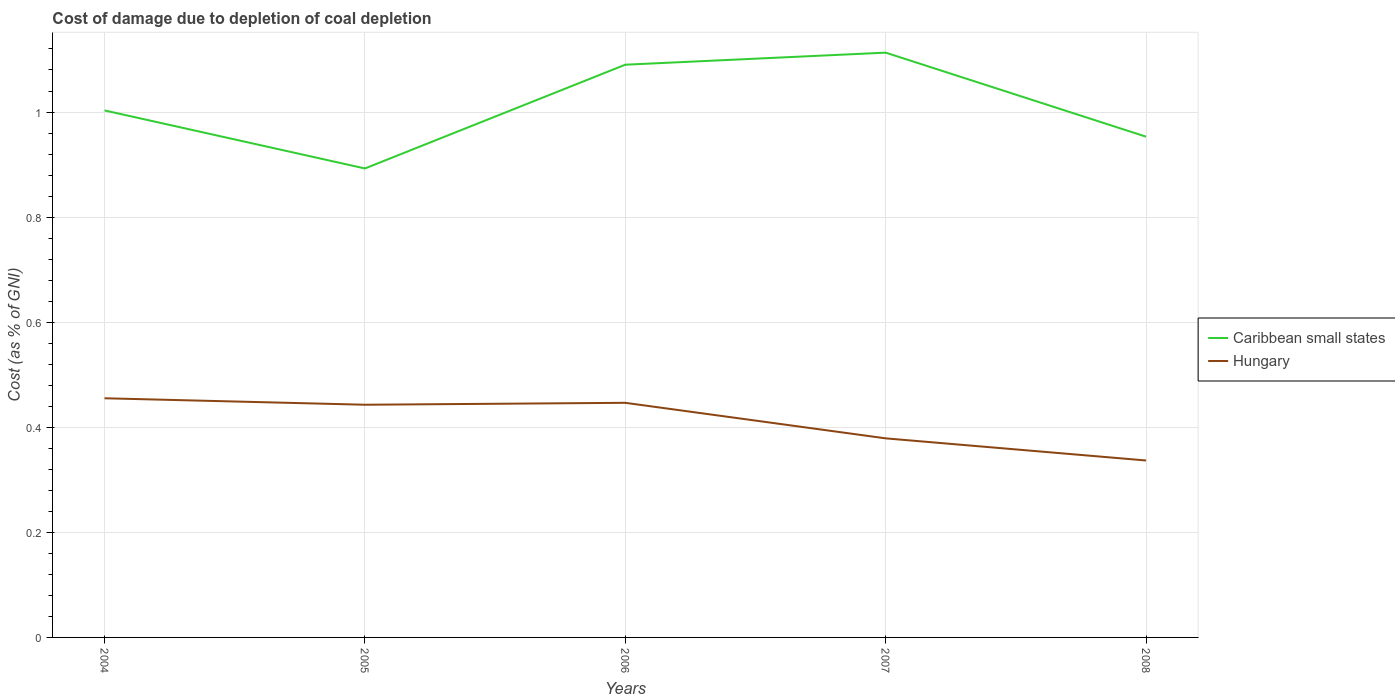Is the number of lines equal to the number of legend labels?
Your response must be concise. Yes. Across all years, what is the maximum cost of damage caused due to coal depletion in Hungary?
Your response must be concise. 0.34. In which year was the cost of damage caused due to coal depletion in Hungary maximum?
Offer a very short reply. 2008. What is the total cost of damage caused due to coal depletion in Hungary in the graph?
Your response must be concise. 0.12. What is the difference between the highest and the second highest cost of damage caused due to coal depletion in Caribbean small states?
Offer a very short reply. 0.22. What is the difference between the highest and the lowest cost of damage caused due to coal depletion in Hungary?
Provide a short and direct response. 3. Is the cost of damage caused due to coal depletion in Hungary strictly greater than the cost of damage caused due to coal depletion in Caribbean small states over the years?
Provide a short and direct response. Yes. Does the graph contain any zero values?
Your answer should be very brief. No. Where does the legend appear in the graph?
Your answer should be compact. Center right. How many legend labels are there?
Make the answer very short. 2. How are the legend labels stacked?
Make the answer very short. Vertical. What is the title of the graph?
Offer a terse response. Cost of damage due to depletion of coal depletion. What is the label or title of the X-axis?
Offer a very short reply. Years. What is the label or title of the Y-axis?
Ensure brevity in your answer.  Cost (as % of GNI). What is the Cost (as % of GNI) of Caribbean small states in 2004?
Offer a very short reply. 1. What is the Cost (as % of GNI) of Hungary in 2004?
Your answer should be very brief. 0.46. What is the Cost (as % of GNI) in Caribbean small states in 2005?
Keep it short and to the point. 0.89. What is the Cost (as % of GNI) of Hungary in 2005?
Offer a terse response. 0.44. What is the Cost (as % of GNI) in Caribbean small states in 2006?
Make the answer very short. 1.09. What is the Cost (as % of GNI) in Hungary in 2006?
Your answer should be very brief. 0.45. What is the Cost (as % of GNI) in Caribbean small states in 2007?
Ensure brevity in your answer.  1.11. What is the Cost (as % of GNI) in Hungary in 2007?
Provide a succinct answer. 0.38. What is the Cost (as % of GNI) in Caribbean small states in 2008?
Your answer should be compact. 0.95. What is the Cost (as % of GNI) of Hungary in 2008?
Offer a very short reply. 0.34. Across all years, what is the maximum Cost (as % of GNI) in Caribbean small states?
Make the answer very short. 1.11. Across all years, what is the maximum Cost (as % of GNI) in Hungary?
Make the answer very short. 0.46. Across all years, what is the minimum Cost (as % of GNI) in Caribbean small states?
Ensure brevity in your answer.  0.89. Across all years, what is the minimum Cost (as % of GNI) in Hungary?
Make the answer very short. 0.34. What is the total Cost (as % of GNI) of Caribbean small states in the graph?
Your answer should be very brief. 5.05. What is the total Cost (as % of GNI) of Hungary in the graph?
Your answer should be very brief. 2.06. What is the difference between the Cost (as % of GNI) in Caribbean small states in 2004 and that in 2005?
Offer a terse response. 0.11. What is the difference between the Cost (as % of GNI) of Hungary in 2004 and that in 2005?
Make the answer very short. 0.01. What is the difference between the Cost (as % of GNI) in Caribbean small states in 2004 and that in 2006?
Give a very brief answer. -0.09. What is the difference between the Cost (as % of GNI) of Hungary in 2004 and that in 2006?
Make the answer very short. 0.01. What is the difference between the Cost (as % of GNI) in Caribbean small states in 2004 and that in 2007?
Ensure brevity in your answer.  -0.11. What is the difference between the Cost (as % of GNI) of Hungary in 2004 and that in 2007?
Keep it short and to the point. 0.08. What is the difference between the Cost (as % of GNI) in Caribbean small states in 2004 and that in 2008?
Your response must be concise. 0.05. What is the difference between the Cost (as % of GNI) of Hungary in 2004 and that in 2008?
Give a very brief answer. 0.12. What is the difference between the Cost (as % of GNI) of Caribbean small states in 2005 and that in 2006?
Provide a succinct answer. -0.2. What is the difference between the Cost (as % of GNI) in Hungary in 2005 and that in 2006?
Make the answer very short. -0. What is the difference between the Cost (as % of GNI) in Caribbean small states in 2005 and that in 2007?
Offer a terse response. -0.22. What is the difference between the Cost (as % of GNI) in Hungary in 2005 and that in 2007?
Offer a very short reply. 0.06. What is the difference between the Cost (as % of GNI) in Caribbean small states in 2005 and that in 2008?
Your response must be concise. -0.06. What is the difference between the Cost (as % of GNI) in Hungary in 2005 and that in 2008?
Provide a short and direct response. 0.11. What is the difference between the Cost (as % of GNI) in Caribbean small states in 2006 and that in 2007?
Offer a very short reply. -0.02. What is the difference between the Cost (as % of GNI) of Hungary in 2006 and that in 2007?
Ensure brevity in your answer.  0.07. What is the difference between the Cost (as % of GNI) of Caribbean small states in 2006 and that in 2008?
Ensure brevity in your answer.  0.14. What is the difference between the Cost (as % of GNI) of Hungary in 2006 and that in 2008?
Make the answer very short. 0.11. What is the difference between the Cost (as % of GNI) of Caribbean small states in 2007 and that in 2008?
Your answer should be very brief. 0.16. What is the difference between the Cost (as % of GNI) of Hungary in 2007 and that in 2008?
Your answer should be compact. 0.04. What is the difference between the Cost (as % of GNI) in Caribbean small states in 2004 and the Cost (as % of GNI) in Hungary in 2005?
Offer a terse response. 0.56. What is the difference between the Cost (as % of GNI) of Caribbean small states in 2004 and the Cost (as % of GNI) of Hungary in 2006?
Make the answer very short. 0.56. What is the difference between the Cost (as % of GNI) of Caribbean small states in 2004 and the Cost (as % of GNI) of Hungary in 2007?
Provide a short and direct response. 0.62. What is the difference between the Cost (as % of GNI) in Caribbean small states in 2004 and the Cost (as % of GNI) in Hungary in 2008?
Offer a very short reply. 0.67. What is the difference between the Cost (as % of GNI) of Caribbean small states in 2005 and the Cost (as % of GNI) of Hungary in 2006?
Provide a succinct answer. 0.45. What is the difference between the Cost (as % of GNI) in Caribbean small states in 2005 and the Cost (as % of GNI) in Hungary in 2007?
Your answer should be compact. 0.51. What is the difference between the Cost (as % of GNI) in Caribbean small states in 2005 and the Cost (as % of GNI) in Hungary in 2008?
Ensure brevity in your answer.  0.56. What is the difference between the Cost (as % of GNI) of Caribbean small states in 2006 and the Cost (as % of GNI) of Hungary in 2007?
Your response must be concise. 0.71. What is the difference between the Cost (as % of GNI) of Caribbean small states in 2006 and the Cost (as % of GNI) of Hungary in 2008?
Ensure brevity in your answer.  0.75. What is the difference between the Cost (as % of GNI) in Caribbean small states in 2007 and the Cost (as % of GNI) in Hungary in 2008?
Your response must be concise. 0.78. What is the average Cost (as % of GNI) of Caribbean small states per year?
Your response must be concise. 1.01. What is the average Cost (as % of GNI) of Hungary per year?
Provide a short and direct response. 0.41. In the year 2004, what is the difference between the Cost (as % of GNI) in Caribbean small states and Cost (as % of GNI) in Hungary?
Your answer should be compact. 0.55. In the year 2005, what is the difference between the Cost (as % of GNI) in Caribbean small states and Cost (as % of GNI) in Hungary?
Your answer should be very brief. 0.45. In the year 2006, what is the difference between the Cost (as % of GNI) of Caribbean small states and Cost (as % of GNI) of Hungary?
Make the answer very short. 0.64. In the year 2007, what is the difference between the Cost (as % of GNI) in Caribbean small states and Cost (as % of GNI) in Hungary?
Your response must be concise. 0.73. In the year 2008, what is the difference between the Cost (as % of GNI) in Caribbean small states and Cost (as % of GNI) in Hungary?
Offer a terse response. 0.62. What is the ratio of the Cost (as % of GNI) of Caribbean small states in 2004 to that in 2005?
Make the answer very short. 1.12. What is the ratio of the Cost (as % of GNI) in Hungary in 2004 to that in 2005?
Keep it short and to the point. 1.03. What is the ratio of the Cost (as % of GNI) of Caribbean small states in 2004 to that in 2006?
Provide a short and direct response. 0.92. What is the ratio of the Cost (as % of GNI) of Hungary in 2004 to that in 2006?
Ensure brevity in your answer.  1.02. What is the ratio of the Cost (as % of GNI) of Caribbean small states in 2004 to that in 2007?
Make the answer very short. 0.9. What is the ratio of the Cost (as % of GNI) of Hungary in 2004 to that in 2007?
Your answer should be very brief. 1.2. What is the ratio of the Cost (as % of GNI) in Caribbean small states in 2004 to that in 2008?
Offer a very short reply. 1.05. What is the ratio of the Cost (as % of GNI) of Hungary in 2004 to that in 2008?
Ensure brevity in your answer.  1.35. What is the ratio of the Cost (as % of GNI) in Caribbean small states in 2005 to that in 2006?
Provide a succinct answer. 0.82. What is the ratio of the Cost (as % of GNI) of Caribbean small states in 2005 to that in 2007?
Ensure brevity in your answer.  0.8. What is the ratio of the Cost (as % of GNI) in Hungary in 2005 to that in 2007?
Ensure brevity in your answer.  1.17. What is the ratio of the Cost (as % of GNI) of Caribbean small states in 2005 to that in 2008?
Your response must be concise. 0.94. What is the ratio of the Cost (as % of GNI) in Hungary in 2005 to that in 2008?
Offer a terse response. 1.32. What is the ratio of the Cost (as % of GNI) in Caribbean small states in 2006 to that in 2007?
Your answer should be compact. 0.98. What is the ratio of the Cost (as % of GNI) in Hungary in 2006 to that in 2007?
Keep it short and to the point. 1.18. What is the ratio of the Cost (as % of GNI) in Caribbean small states in 2006 to that in 2008?
Ensure brevity in your answer.  1.14. What is the ratio of the Cost (as % of GNI) in Hungary in 2006 to that in 2008?
Provide a succinct answer. 1.33. What is the ratio of the Cost (as % of GNI) in Caribbean small states in 2007 to that in 2008?
Your answer should be compact. 1.17. What is the ratio of the Cost (as % of GNI) in Hungary in 2007 to that in 2008?
Your answer should be compact. 1.13. What is the difference between the highest and the second highest Cost (as % of GNI) of Caribbean small states?
Make the answer very short. 0.02. What is the difference between the highest and the second highest Cost (as % of GNI) of Hungary?
Provide a succinct answer. 0.01. What is the difference between the highest and the lowest Cost (as % of GNI) in Caribbean small states?
Keep it short and to the point. 0.22. What is the difference between the highest and the lowest Cost (as % of GNI) in Hungary?
Offer a terse response. 0.12. 